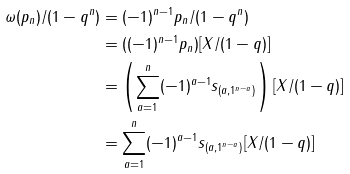<formula> <loc_0><loc_0><loc_500><loc_500>\omega ( p _ { n } ) / ( 1 - q ^ { n } ) & = ( - 1 ) ^ { n - 1 } p _ { n } / ( 1 - q ^ { n } ) \\ & = ( ( - 1 ) ^ { n - 1 } p _ { n } ) [ X / ( 1 - q ) ] \\ & = \left ( \sum _ { a = 1 } ^ { n } ( - 1 ) ^ { a - 1 } s _ { ( a , 1 ^ { n - a } ) } \right ) [ X / ( 1 - q ) ] \\ & = \sum _ { a = 1 } ^ { n } ( - 1 ) ^ { a - 1 } s _ { ( a , 1 ^ { n - a } ) } [ X / ( 1 - q ) ]</formula> 